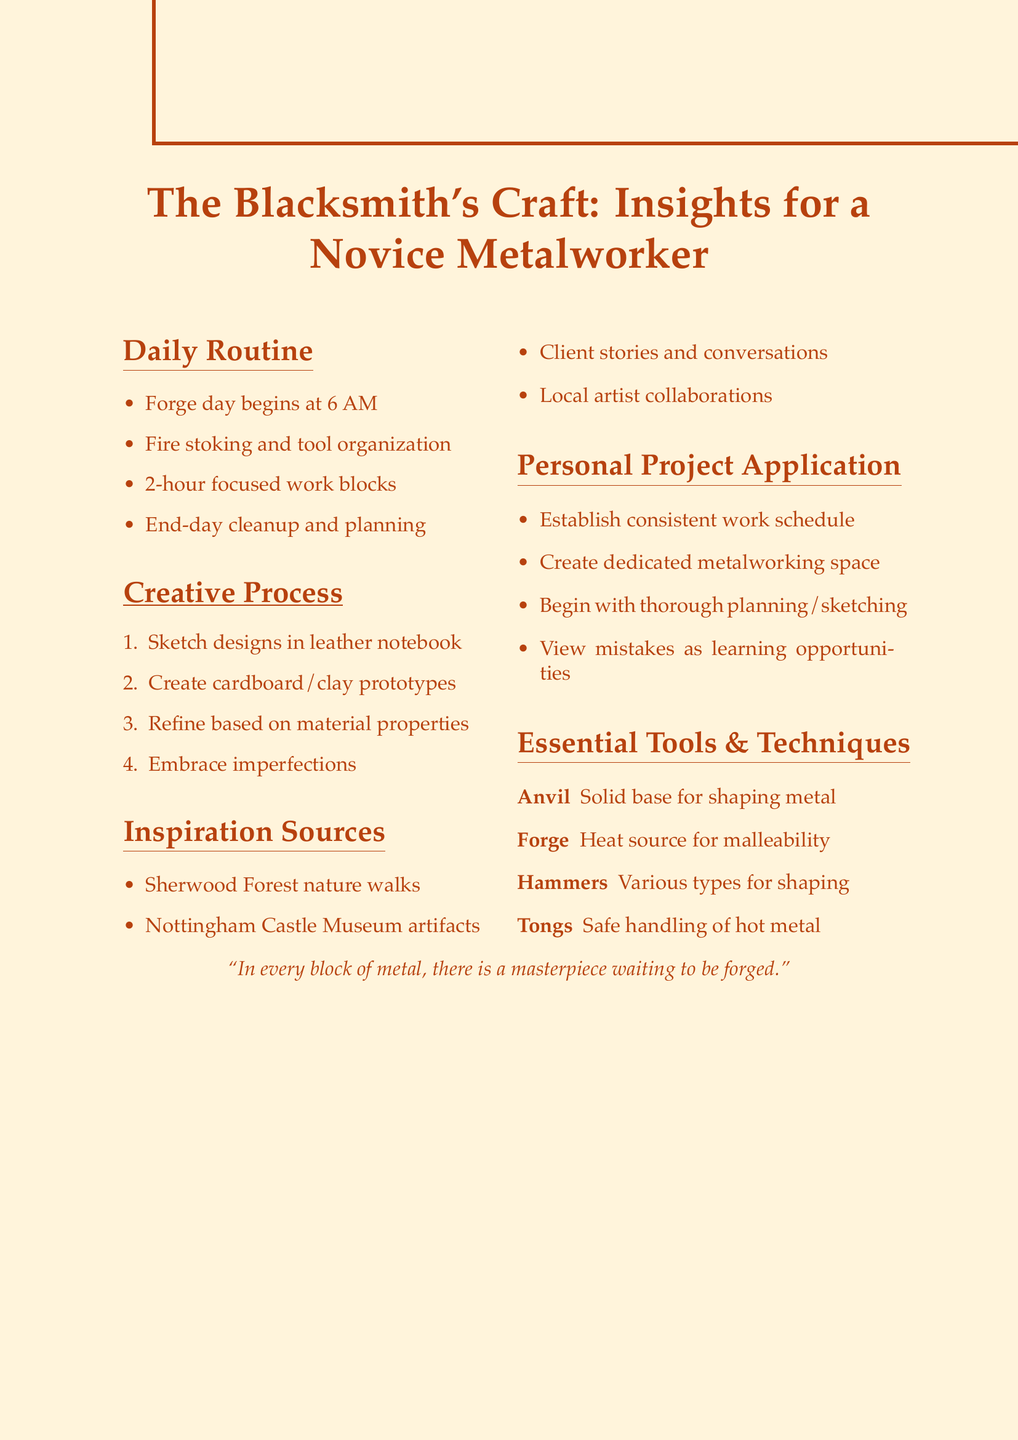What time does the blacksmith arrive at the forge? The document states that the blacksmith arrives at the forge at 6 AM.
Answer: 6 AM What are the first tasks of the blacksmith's routine? The document lists that the first tasks include stoking the fire and organizing tools.
Answer: Stoking the fire and organizing tools How long are the focused work blocks? The document indicates that the blacksmith works in focused 2-hour blocks.
Answer: 2-hour What is one source of inspiration mentioned? The document lists several inspiration sources, one of which is nature walks in nearby Sherwood Forest.
Answer: Nature walks in nearby Sherwood Forest Which type of notebook does the blacksmith use for sketching? According to the document, the blacksmith sketches designs in a leather-bound notebook.
Answer: Leather-bound notebook What is a key insight for applying the blacksmith's methods to personal projects? The document suggests establishing a consistent work schedule as a key insight.
Answer: Establish a consistent work schedule What is the essential tool for safely handling hot metal? The document states that tongs are the essential tool for safely handling hot metal.
Answer: Tongs How does the blacksmith approach imperfections in his work? The document mentions that the blacksmith embraces imperfections as unique characteristics.
Answer: Embraces imperfections What should be created for dedicated metalworking? The document advises creating a dedicated workspace for metalworking.
Answer: A dedicated workspace for metalworking 